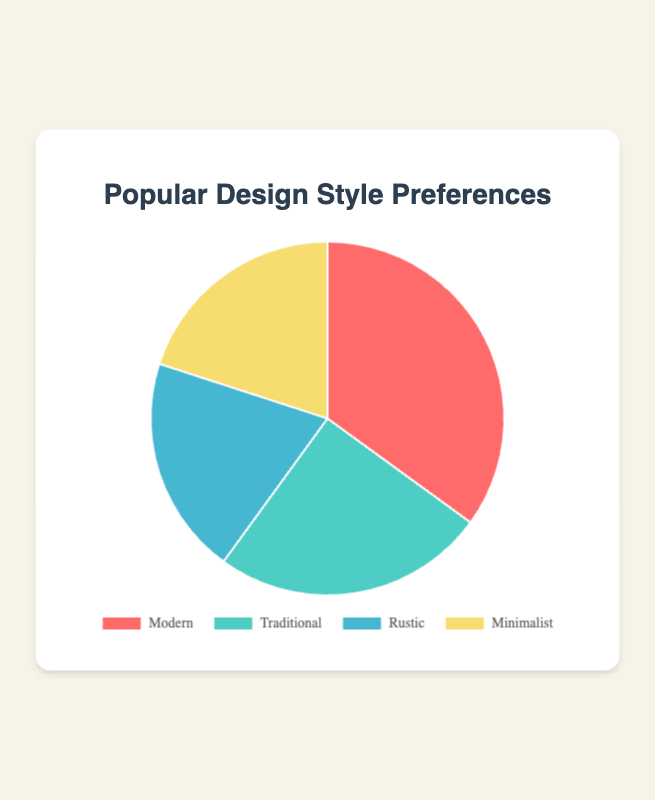What percentage of people prefer Modern design styles compared to Traditional? First, identify the percentages of Modern and Traditional from the chart, which are 35% and 25% respectively. The percentage difference is calculated as 35% - 25% = 10%.
Answer: 10% Which design style is the most popular? Look at the chart to see which design style has the largest segment. The Modern design style has the largest percentage, which is 35%.
Answer: Modern How much larger is the percentage of Minimalist preferences compared to Rustic? The percentages for Minimalist and Rustic are both 20%, so calculate the difference, which is 20% - 20% = 0%.
Answer: 0% What is the combined percentage of people who prefer Rustic and Minimalist styles? Add the percentages of people who prefer Rustic and Minimalist, which are 20% + 20% = 40%.
Answer: 40% Which design style received the least preference, and what is the percentage? Find the smallest segment in the pie chart. Both Rustic and Minimalist received the least preference, with 20% each.
Answer: Rustic and Minimalist (20%) What fraction of people prefer either Traditional or Rustic styles? Sum the percentages of Traditional and Rustic preferences: 25% (Traditional) + 20% (Rustic) = 45%. Convert this percentage to a fraction: 45% = 45/100 = 9/20.
Answer: 9/20 What is the difference in percentage between the most and least popular design styles? Identify the most popular style (Modern, 35%) and the least popular styles (Rustic and Minimalist, each 20%). Calculate the difference: 35% - 20% = 15%.
Answer: 15% Which design style has an equal percentage of preference to Minimalist? Look at the chart to find the segment with the same percentage as Minimalist, which has 20%. The Rustic design style also has 20%.
Answer: Rustic What is the total percentage represented by Modern and Traditional preferences together? Add the percentages of people who prefer Modern and Traditional styles: 35% + 25% = 60%.
Answer: 60% How does the Modern design style preference compare visually to the Traditional style on the pie chart? Observe the chart to compare the sizes of the segments representing each style. The Modern segment is visibly larger than the Traditional segment because it has a higher percentage (35% vs. 25%).
Answer: Modern is larger 